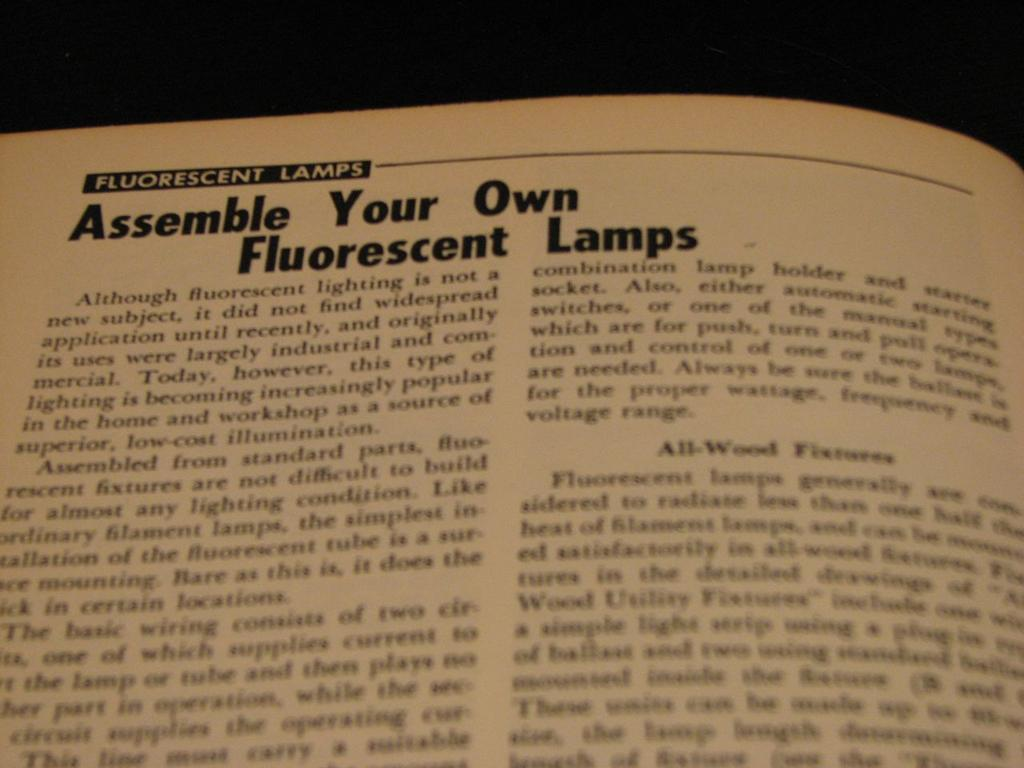<image>
Share a concise interpretation of the image provided. A page describes how to assemble your own fluorescent lamps. 